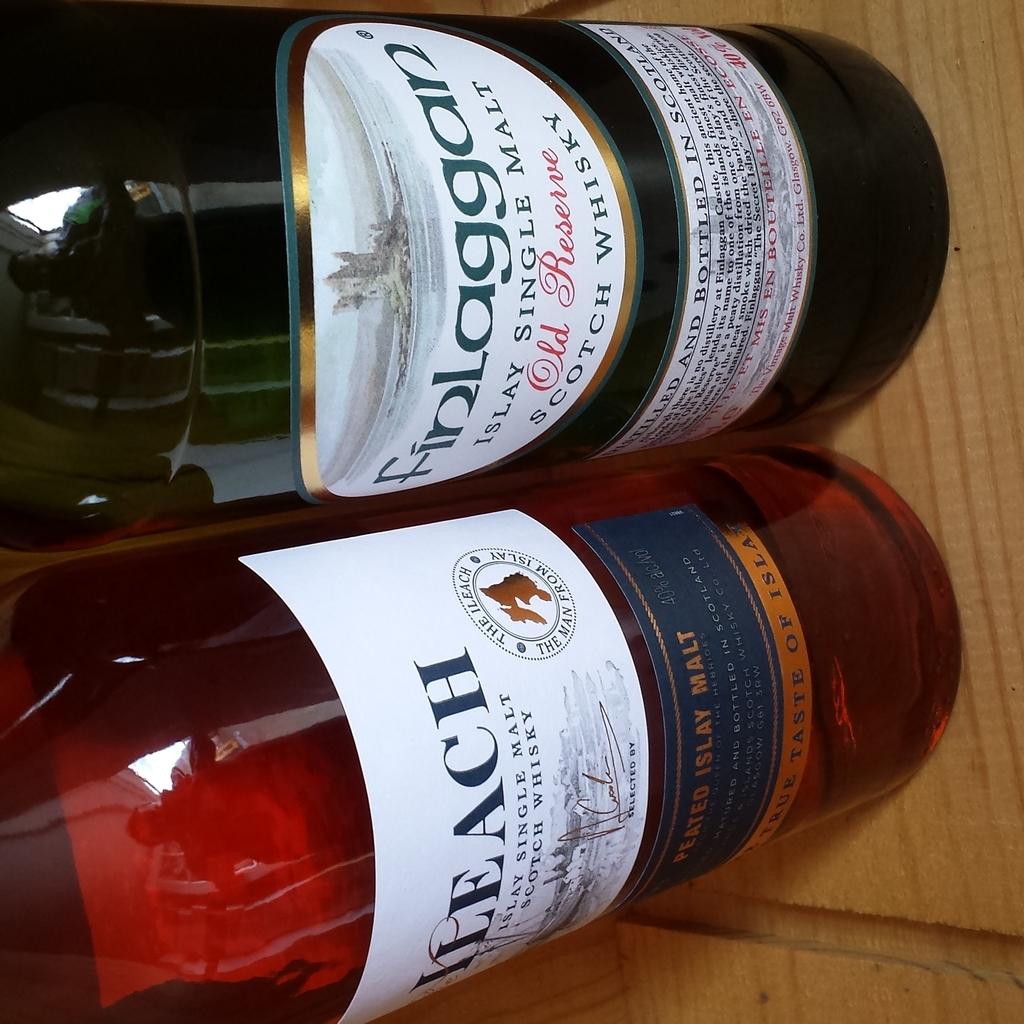What is the name of the scotch whiskey?
Your response must be concise. Finlaggan. What kind of whisky is shown?
Give a very brief answer. Scotch. 